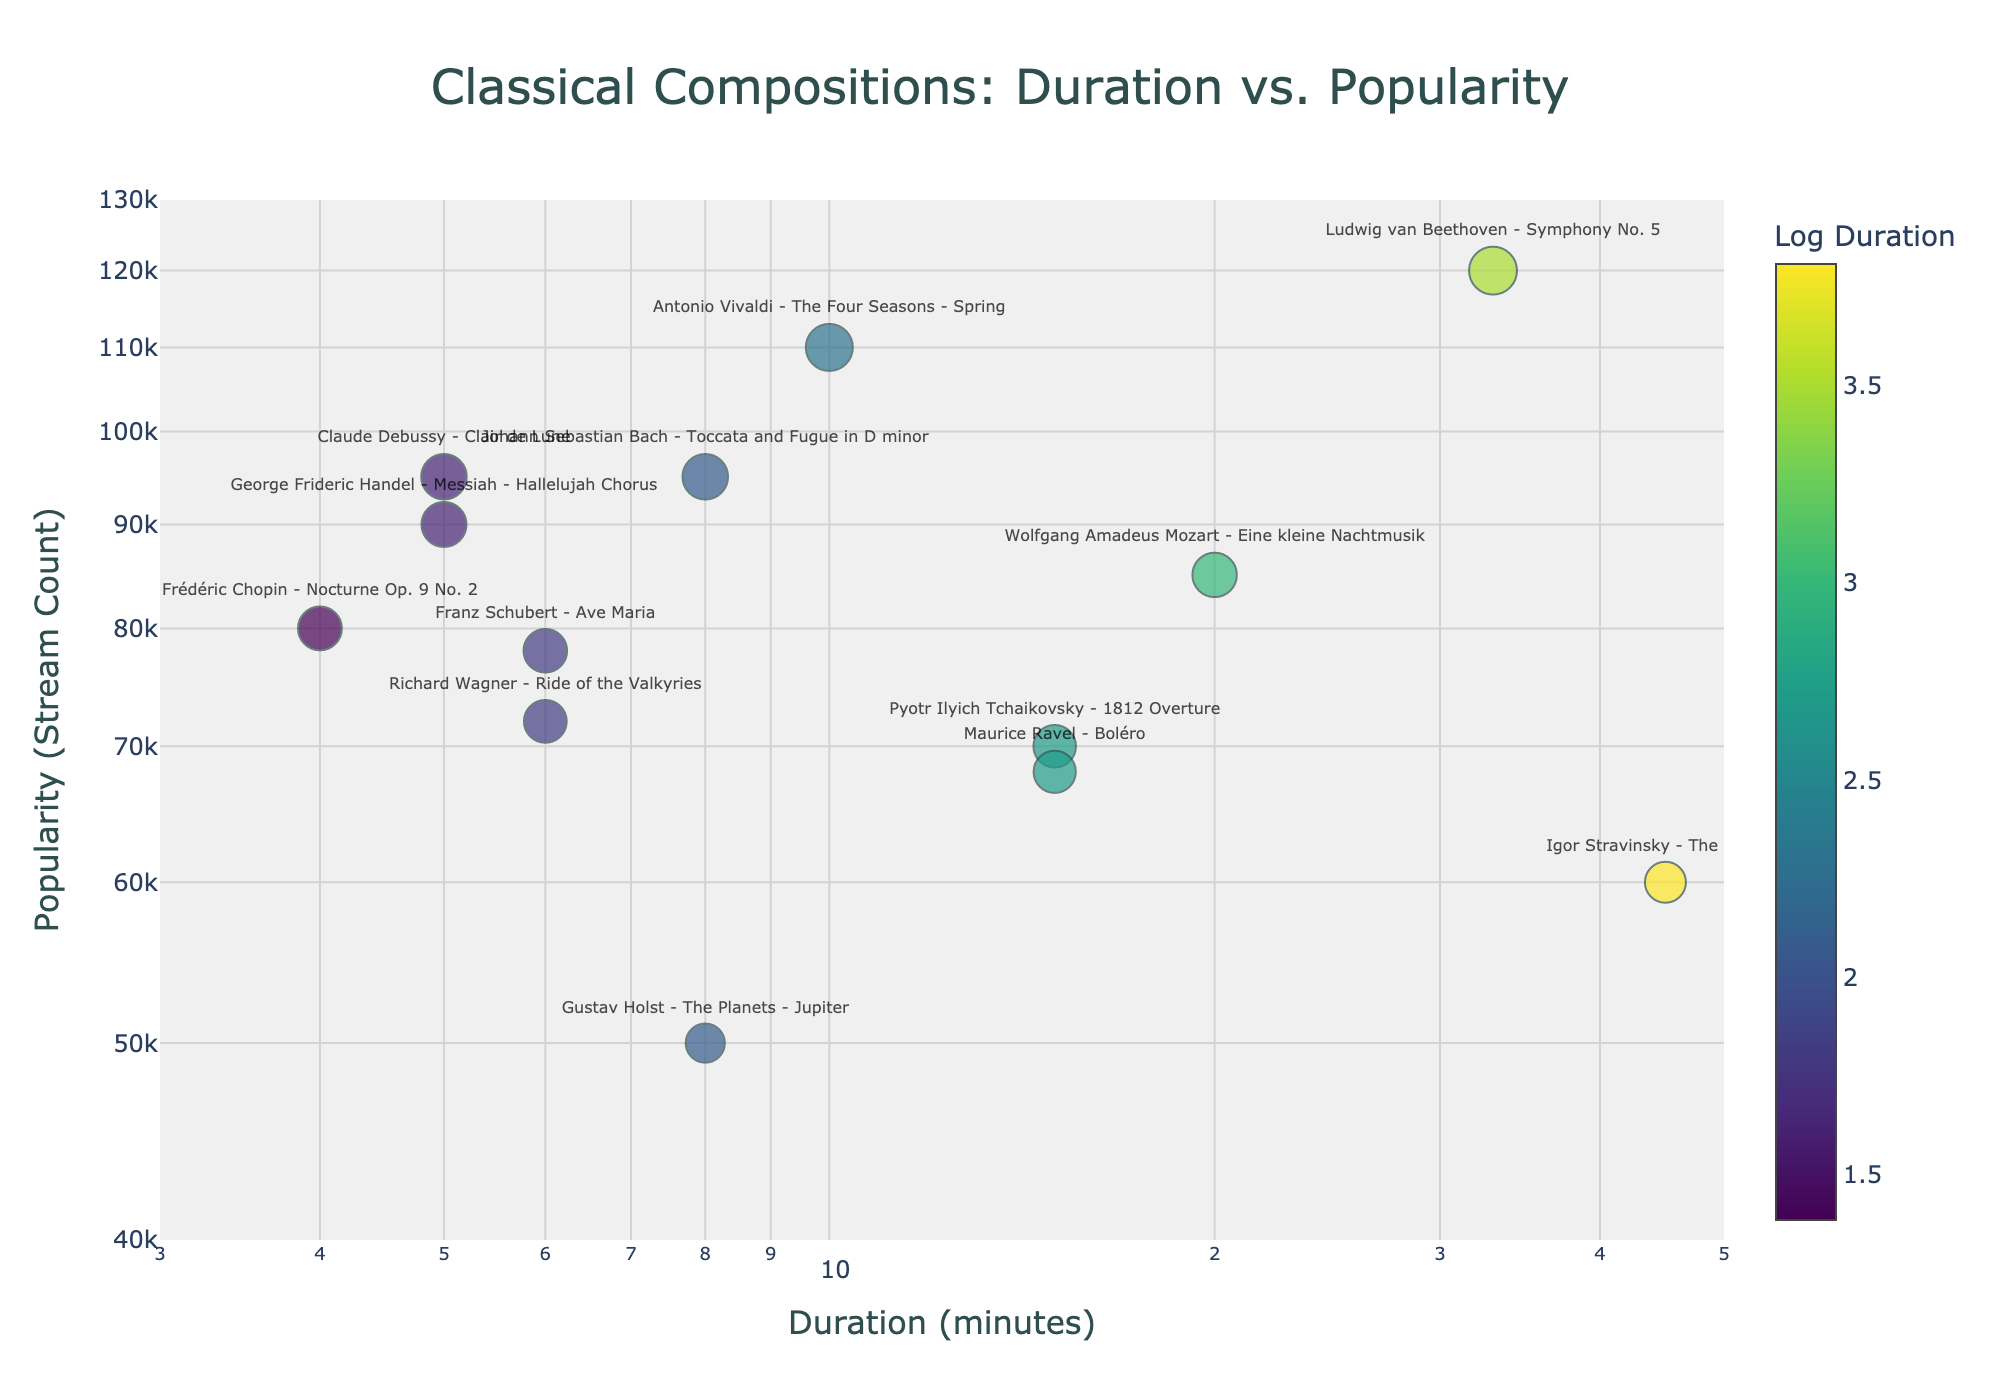what is the title of the plot? The title is located at the top center of the plot, with increased font size and in a distinct color. It provides a summary of what the plot is about.
Answer: Classical Compositions: Duration vs. Popularity how many compositions have a duration of exactly 6 minutes? To find the number of compositions with a specific duration, look at the x-axis for the value 6 and count the data points aligned vertically, above or below this value along the y-axis.
Answer: 2 which composition is the most popular? The most popular composition will be the one with the highest y-value (stream counts) when plotted.
Answer: Ludwig van Beethoven - Symphony No. 5 what's the difference in stream counts between Toccata and Fugue in D minor and Clair de Lune? First, find the y-values (stream counts) for both compositions, then subtract the smaller count from the larger one to get the difference. For Toccata and Fugue in D minor, the popularity is 95,000 and for Clair de Lune it is also 95,000.
Answer: 0 are shorter compositions generally more popular than longer ones? Observe the general trend of data points from shorter to longer durations (x-axis) and see whether stream counts (y-axis) change accordingly. Typically, in a trend comparison, check if points on the left (shorter durations) appear higher (more streams) compared to those on the right.
Answer: Yes which composition has the longest duration? To determine this, identify the composition at the far right end of the x-axis which will indicate the maximum duration.
Answer: Igor Stravinsky - The Firebird what color represents compositions with a log duration closest to 1 on the color scale? By referring to the colorbar legend, locate the color that corresponds to a log duration near 1. The closer the numeric value to 1, the more accurate the color identification.
Answer: Dark color (likely approaching dark green or yellow in the Viridis scale) which composition has a duration less than 10 minutes but a popularity higher than 70,000? Look for data points to the left of the 10-minute mark on the x-axis and check if their y-values exceed 70,000 on the y-axis.
Answer: Franz Schubert - Ave Maria what is the average duration of compositions exceeding 80,000 stream counts? Identify compositions with popularity greater than 80,000, add their durations, and then divide by the number of such compositions. For example, Symphony No. 5 (33) + Eine kleine Nachtmusik (20) + Toccata and Fugue in D Minor (8) + The Four Seasons - Spring (10) + Messiah - Hallelujah Chorus (5) + Clair de Lune (5) = 81. Hence, the average: 81 / 6.
Answer: 13.5 minutes 